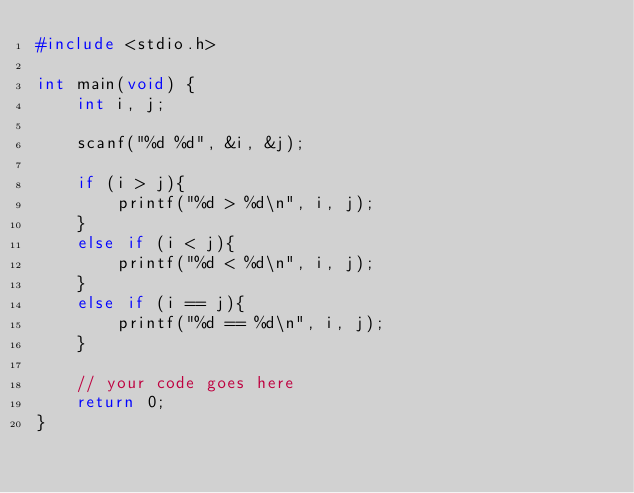Convert code to text. <code><loc_0><loc_0><loc_500><loc_500><_C_>#include <stdio.h>

int main(void) {
	int i, j;
	
	scanf("%d %d", &i, &j);
	
	if (i > j){
		printf("%d > %d\n", i, j);
	}
	else if (i < j){
		printf("%d < %d\n", i, j);
	}
	else if (i == j){
		printf("%d == %d\n", i, j);
	}
	
	// your code goes here
	return 0;
}</code> 